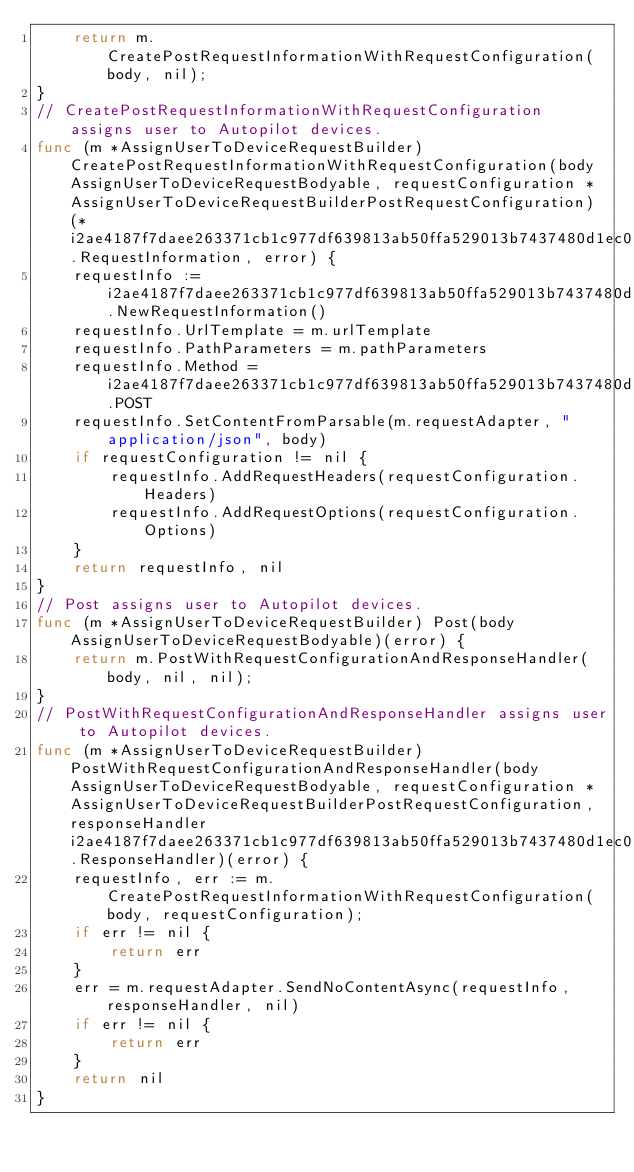Convert code to text. <code><loc_0><loc_0><loc_500><loc_500><_Go_>    return m.CreatePostRequestInformationWithRequestConfiguration(body, nil);
}
// CreatePostRequestInformationWithRequestConfiguration assigns user to Autopilot devices.
func (m *AssignUserToDeviceRequestBuilder) CreatePostRequestInformationWithRequestConfiguration(body AssignUserToDeviceRequestBodyable, requestConfiguration *AssignUserToDeviceRequestBuilderPostRequestConfiguration)(*i2ae4187f7daee263371cb1c977df639813ab50ffa529013b7437480d1ec0158f.RequestInformation, error) {
    requestInfo := i2ae4187f7daee263371cb1c977df639813ab50ffa529013b7437480d1ec0158f.NewRequestInformation()
    requestInfo.UrlTemplate = m.urlTemplate
    requestInfo.PathParameters = m.pathParameters
    requestInfo.Method = i2ae4187f7daee263371cb1c977df639813ab50ffa529013b7437480d1ec0158f.POST
    requestInfo.SetContentFromParsable(m.requestAdapter, "application/json", body)
    if requestConfiguration != nil {
        requestInfo.AddRequestHeaders(requestConfiguration.Headers)
        requestInfo.AddRequestOptions(requestConfiguration.Options)
    }
    return requestInfo, nil
}
// Post assigns user to Autopilot devices.
func (m *AssignUserToDeviceRequestBuilder) Post(body AssignUserToDeviceRequestBodyable)(error) {
    return m.PostWithRequestConfigurationAndResponseHandler(body, nil, nil);
}
// PostWithRequestConfigurationAndResponseHandler assigns user to Autopilot devices.
func (m *AssignUserToDeviceRequestBuilder) PostWithRequestConfigurationAndResponseHandler(body AssignUserToDeviceRequestBodyable, requestConfiguration *AssignUserToDeviceRequestBuilderPostRequestConfiguration, responseHandler i2ae4187f7daee263371cb1c977df639813ab50ffa529013b7437480d1ec0158f.ResponseHandler)(error) {
    requestInfo, err := m.CreatePostRequestInformationWithRequestConfiguration(body, requestConfiguration);
    if err != nil {
        return err
    }
    err = m.requestAdapter.SendNoContentAsync(requestInfo, responseHandler, nil)
    if err != nil {
        return err
    }
    return nil
}
</code> 